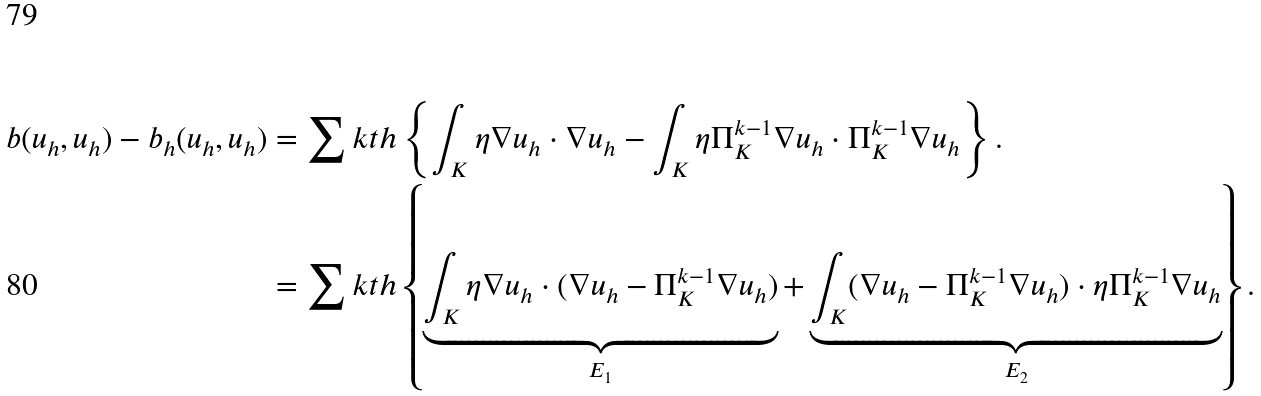<formula> <loc_0><loc_0><loc_500><loc_500>b ( u _ { h } , u _ { h } ) - b _ { h } ( u _ { h } , u _ { h } ) & = \sum k t h \left \{ \int _ { K } \eta \nabla u _ { h } \cdot \nabla u _ { h } - \int _ { K } \eta \Pi _ { K } ^ { k - 1 } \nabla u _ { h } \cdot \Pi _ { K } ^ { k - 1 } \nabla u _ { h } \right \} . \\ & = \sum k t h \left \{ \underbrace { \int _ { K } \eta \nabla u _ { h } \cdot ( \nabla u _ { h } - \Pi _ { K } ^ { k - 1 } \nabla u _ { h } ) } _ { E _ { 1 } } + \underbrace { \int _ { K } ( \nabla u _ { h } - \Pi _ { K } ^ { k - 1 } \nabla u _ { h } ) \cdot \eta \Pi _ { K } ^ { k - 1 } \nabla u _ { h } } _ { E _ { 2 } } \right \} .</formula> 